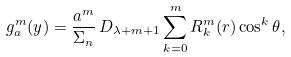<formula> <loc_0><loc_0><loc_500><loc_500>g _ { a } ^ { m } ( y ) = \frac { a ^ { m } } { \Sigma _ { n } } \, D _ { \lambda + m + 1 } \sum _ { k = 0 } ^ { m } R _ { k } ^ { m } ( r ) \cos ^ { k } \theta ,</formula> 